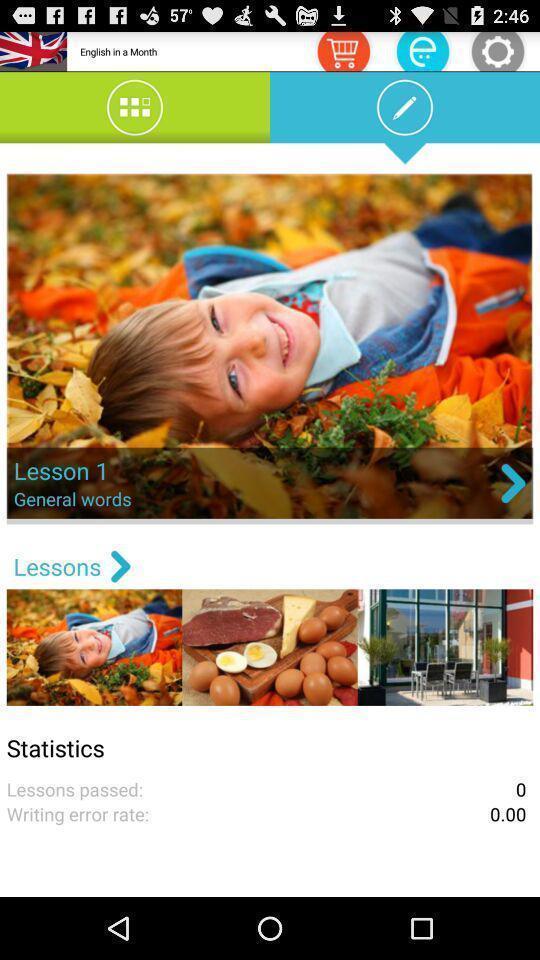What is the overall content of this screenshot? Screen displaying the options in leaning app. 